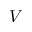<formula> <loc_0><loc_0><loc_500><loc_500>V</formula> 